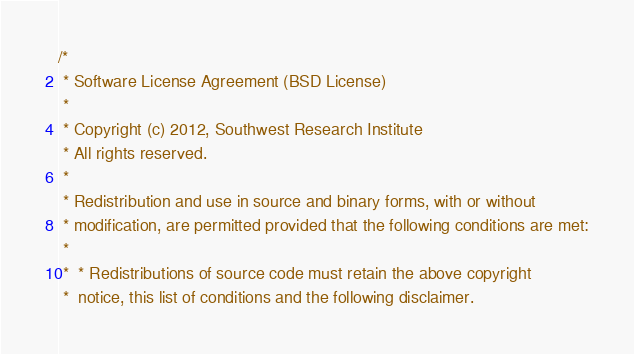Convert code to text. <code><loc_0><loc_0><loc_500><loc_500><_C++_>/*
 * Software License Agreement (BSD License)
 *
 * Copyright (c) 2012, Southwest Research Institute
 * All rights reserved.
 *
 * Redistribution and use in source and binary forms, with or without
 * modification, are permitted provided that the following conditions are met:
 *
 * 	* Redistributions of source code must retain the above copyright
 * 	notice, this list of conditions and the following disclaimer.</code> 